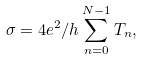Convert formula to latex. <formula><loc_0><loc_0><loc_500><loc_500>\sigma = 4 e ^ { 2 } / h \sum _ { n = 0 } ^ { N - 1 } T _ { n } ,</formula> 